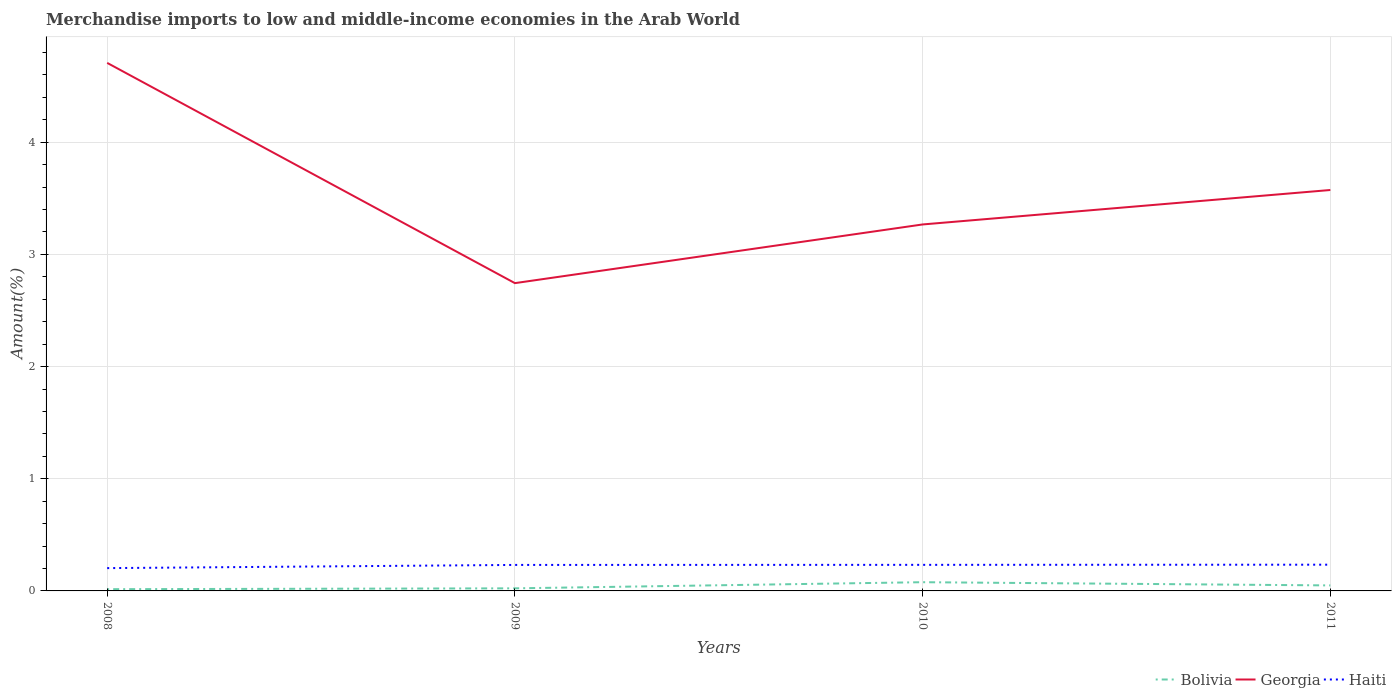How many different coloured lines are there?
Offer a terse response. 3. Does the line corresponding to Georgia intersect with the line corresponding to Haiti?
Keep it short and to the point. No. Is the number of lines equal to the number of legend labels?
Keep it short and to the point. Yes. Across all years, what is the maximum percentage of amount earned from merchandise imports in Georgia?
Make the answer very short. 2.74. What is the total percentage of amount earned from merchandise imports in Bolivia in the graph?
Provide a short and direct response. -0.06. What is the difference between the highest and the second highest percentage of amount earned from merchandise imports in Georgia?
Your answer should be compact. 1.96. How many lines are there?
Make the answer very short. 3. What is the difference between two consecutive major ticks on the Y-axis?
Offer a terse response. 1. Does the graph contain grids?
Offer a terse response. Yes. How many legend labels are there?
Your answer should be very brief. 3. What is the title of the graph?
Your answer should be compact. Merchandise imports to low and middle-income economies in the Arab World. What is the label or title of the Y-axis?
Your answer should be compact. Amount(%). What is the Amount(%) of Bolivia in 2008?
Your response must be concise. 0.02. What is the Amount(%) of Georgia in 2008?
Your answer should be very brief. 4.71. What is the Amount(%) in Haiti in 2008?
Provide a succinct answer. 0.2. What is the Amount(%) in Bolivia in 2009?
Your answer should be compact. 0.02. What is the Amount(%) of Georgia in 2009?
Your response must be concise. 2.74. What is the Amount(%) in Haiti in 2009?
Provide a short and direct response. 0.23. What is the Amount(%) of Bolivia in 2010?
Keep it short and to the point. 0.08. What is the Amount(%) of Georgia in 2010?
Ensure brevity in your answer.  3.27. What is the Amount(%) in Haiti in 2010?
Your answer should be very brief. 0.23. What is the Amount(%) of Bolivia in 2011?
Ensure brevity in your answer.  0.05. What is the Amount(%) of Georgia in 2011?
Make the answer very short. 3.57. What is the Amount(%) of Haiti in 2011?
Keep it short and to the point. 0.23. Across all years, what is the maximum Amount(%) in Bolivia?
Offer a terse response. 0.08. Across all years, what is the maximum Amount(%) in Georgia?
Make the answer very short. 4.71. Across all years, what is the maximum Amount(%) in Haiti?
Make the answer very short. 0.23. Across all years, what is the minimum Amount(%) in Bolivia?
Your answer should be compact. 0.02. Across all years, what is the minimum Amount(%) in Georgia?
Offer a very short reply. 2.74. Across all years, what is the minimum Amount(%) in Haiti?
Give a very brief answer. 0.2. What is the total Amount(%) of Bolivia in the graph?
Ensure brevity in your answer.  0.17. What is the total Amount(%) of Georgia in the graph?
Offer a terse response. 14.29. What is the total Amount(%) of Haiti in the graph?
Keep it short and to the point. 0.9. What is the difference between the Amount(%) of Bolivia in 2008 and that in 2009?
Keep it short and to the point. -0.01. What is the difference between the Amount(%) in Georgia in 2008 and that in 2009?
Your answer should be very brief. 1.96. What is the difference between the Amount(%) in Haiti in 2008 and that in 2009?
Your response must be concise. -0.03. What is the difference between the Amount(%) in Bolivia in 2008 and that in 2010?
Provide a short and direct response. -0.06. What is the difference between the Amount(%) in Georgia in 2008 and that in 2010?
Offer a terse response. 1.44. What is the difference between the Amount(%) in Haiti in 2008 and that in 2010?
Keep it short and to the point. -0.03. What is the difference between the Amount(%) of Bolivia in 2008 and that in 2011?
Provide a succinct answer. -0.03. What is the difference between the Amount(%) in Georgia in 2008 and that in 2011?
Make the answer very short. 1.13. What is the difference between the Amount(%) of Haiti in 2008 and that in 2011?
Your answer should be compact. -0.03. What is the difference between the Amount(%) of Bolivia in 2009 and that in 2010?
Ensure brevity in your answer.  -0.05. What is the difference between the Amount(%) of Georgia in 2009 and that in 2010?
Offer a very short reply. -0.52. What is the difference between the Amount(%) in Haiti in 2009 and that in 2010?
Keep it short and to the point. -0. What is the difference between the Amount(%) in Bolivia in 2009 and that in 2011?
Keep it short and to the point. -0.03. What is the difference between the Amount(%) of Georgia in 2009 and that in 2011?
Your answer should be very brief. -0.83. What is the difference between the Amount(%) of Haiti in 2009 and that in 2011?
Offer a very short reply. -0. What is the difference between the Amount(%) in Bolivia in 2010 and that in 2011?
Provide a succinct answer. 0.03. What is the difference between the Amount(%) in Georgia in 2010 and that in 2011?
Your response must be concise. -0.31. What is the difference between the Amount(%) in Haiti in 2010 and that in 2011?
Make the answer very short. -0. What is the difference between the Amount(%) in Bolivia in 2008 and the Amount(%) in Georgia in 2009?
Your response must be concise. -2.73. What is the difference between the Amount(%) of Bolivia in 2008 and the Amount(%) of Haiti in 2009?
Offer a very short reply. -0.22. What is the difference between the Amount(%) in Georgia in 2008 and the Amount(%) in Haiti in 2009?
Ensure brevity in your answer.  4.48. What is the difference between the Amount(%) in Bolivia in 2008 and the Amount(%) in Georgia in 2010?
Keep it short and to the point. -3.25. What is the difference between the Amount(%) in Bolivia in 2008 and the Amount(%) in Haiti in 2010?
Provide a succinct answer. -0.22. What is the difference between the Amount(%) of Georgia in 2008 and the Amount(%) of Haiti in 2010?
Make the answer very short. 4.47. What is the difference between the Amount(%) of Bolivia in 2008 and the Amount(%) of Georgia in 2011?
Offer a terse response. -3.56. What is the difference between the Amount(%) of Bolivia in 2008 and the Amount(%) of Haiti in 2011?
Your answer should be very brief. -0.22. What is the difference between the Amount(%) in Georgia in 2008 and the Amount(%) in Haiti in 2011?
Your answer should be compact. 4.47. What is the difference between the Amount(%) of Bolivia in 2009 and the Amount(%) of Georgia in 2010?
Your answer should be very brief. -3.24. What is the difference between the Amount(%) of Bolivia in 2009 and the Amount(%) of Haiti in 2010?
Provide a succinct answer. -0.21. What is the difference between the Amount(%) of Georgia in 2009 and the Amount(%) of Haiti in 2010?
Offer a very short reply. 2.51. What is the difference between the Amount(%) of Bolivia in 2009 and the Amount(%) of Georgia in 2011?
Your response must be concise. -3.55. What is the difference between the Amount(%) of Bolivia in 2009 and the Amount(%) of Haiti in 2011?
Your response must be concise. -0.21. What is the difference between the Amount(%) in Georgia in 2009 and the Amount(%) in Haiti in 2011?
Provide a succinct answer. 2.51. What is the difference between the Amount(%) in Bolivia in 2010 and the Amount(%) in Georgia in 2011?
Provide a succinct answer. -3.5. What is the difference between the Amount(%) in Bolivia in 2010 and the Amount(%) in Haiti in 2011?
Provide a succinct answer. -0.16. What is the difference between the Amount(%) in Georgia in 2010 and the Amount(%) in Haiti in 2011?
Your answer should be compact. 3.03. What is the average Amount(%) in Bolivia per year?
Give a very brief answer. 0.04. What is the average Amount(%) of Georgia per year?
Keep it short and to the point. 3.57. What is the average Amount(%) of Haiti per year?
Make the answer very short. 0.23. In the year 2008, what is the difference between the Amount(%) in Bolivia and Amount(%) in Georgia?
Provide a short and direct response. -4.69. In the year 2008, what is the difference between the Amount(%) of Bolivia and Amount(%) of Haiti?
Give a very brief answer. -0.19. In the year 2008, what is the difference between the Amount(%) of Georgia and Amount(%) of Haiti?
Offer a terse response. 4.5. In the year 2009, what is the difference between the Amount(%) in Bolivia and Amount(%) in Georgia?
Give a very brief answer. -2.72. In the year 2009, what is the difference between the Amount(%) in Bolivia and Amount(%) in Haiti?
Give a very brief answer. -0.21. In the year 2009, what is the difference between the Amount(%) of Georgia and Amount(%) of Haiti?
Offer a terse response. 2.51. In the year 2010, what is the difference between the Amount(%) in Bolivia and Amount(%) in Georgia?
Provide a succinct answer. -3.19. In the year 2010, what is the difference between the Amount(%) in Bolivia and Amount(%) in Haiti?
Keep it short and to the point. -0.15. In the year 2010, what is the difference between the Amount(%) in Georgia and Amount(%) in Haiti?
Offer a very short reply. 3.03. In the year 2011, what is the difference between the Amount(%) of Bolivia and Amount(%) of Georgia?
Offer a very short reply. -3.52. In the year 2011, what is the difference between the Amount(%) in Bolivia and Amount(%) in Haiti?
Your answer should be compact. -0.18. In the year 2011, what is the difference between the Amount(%) of Georgia and Amount(%) of Haiti?
Provide a succinct answer. 3.34. What is the ratio of the Amount(%) of Bolivia in 2008 to that in 2009?
Give a very brief answer. 0.67. What is the ratio of the Amount(%) in Georgia in 2008 to that in 2009?
Your response must be concise. 1.72. What is the ratio of the Amount(%) of Haiti in 2008 to that in 2009?
Your answer should be compact. 0.88. What is the ratio of the Amount(%) of Bolivia in 2008 to that in 2010?
Your response must be concise. 0.2. What is the ratio of the Amount(%) in Georgia in 2008 to that in 2010?
Make the answer very short. 1.44. What is the ratio of the Amount(%) of Haiti in 2008 to that in 2010?
Your answer should be very brief. 0.87. What is the ratio of the Amount(%) in Bolivia in 2008 to that in 2011?
Provide a succinct answer. 0.32. What is the ratio of the Amount(%) of Georgia in 2008 to that in 2011?
Offer a terse response. 1.32. What is the ratio of the Amount(%) in Haiti in 2008 to that in 2011?
Offer a very short reply. 0.87. What is the ratio of the Amount(%) in Bolivia in 2009 to that in 2010?
Offer a very short reply. 0.3. What is the ratio of the Amount(%) in Georgia in 2009 to that in 2010?
Provide a succinct answer. 0.84. What is the ratio of the Amount(%) in Haiti in 2009 to that in 2010?
Ensure brevity in your answer.  1. What is the ratio of the Amount(%) of Bolivia in 2009 to that in 2011?
Offer a terse response. 0.47. What is the ratio of the Amount(%) in Georgia in 2009 to that in 2011?
Keep it short and to the point. 0.77. What is the ratio of the Amount(%) in Bolivia in 2010 to that in 2011?
Your answer should be very brief. 1.58. What is the ratio of the Amount(%) in Georgia in 2010 to that in 2011?
Give a very brief answer. 0.91. What is the ratio of the Amount(%) of Haiti in 2010 to that in 2011?
Give a very brief answer. 0.99. What is the difference between the highest and the second highest Amount(%) of Bolivia?
Ensure brevity in your answer.  0.03. What is the difference between the highest and the second highest Amount(%) in Georgia?
Your response must be concise. 1.13. What is the difference between the highest and the second highest Amount(%) of Haiti?
Make the answer very short. 0. What is the difference between the highest and the lowest Amount(%) in Bolivia?
Your answer should be very brief. 0.06. What is the difference between the highest and the lowest Amount(%) of Georgia?
Provide a short and direct response. 1.96. What is the difference between the highest and the lowest Amount(%) in Haiti?
Provide a short and direct response. 0.03. 